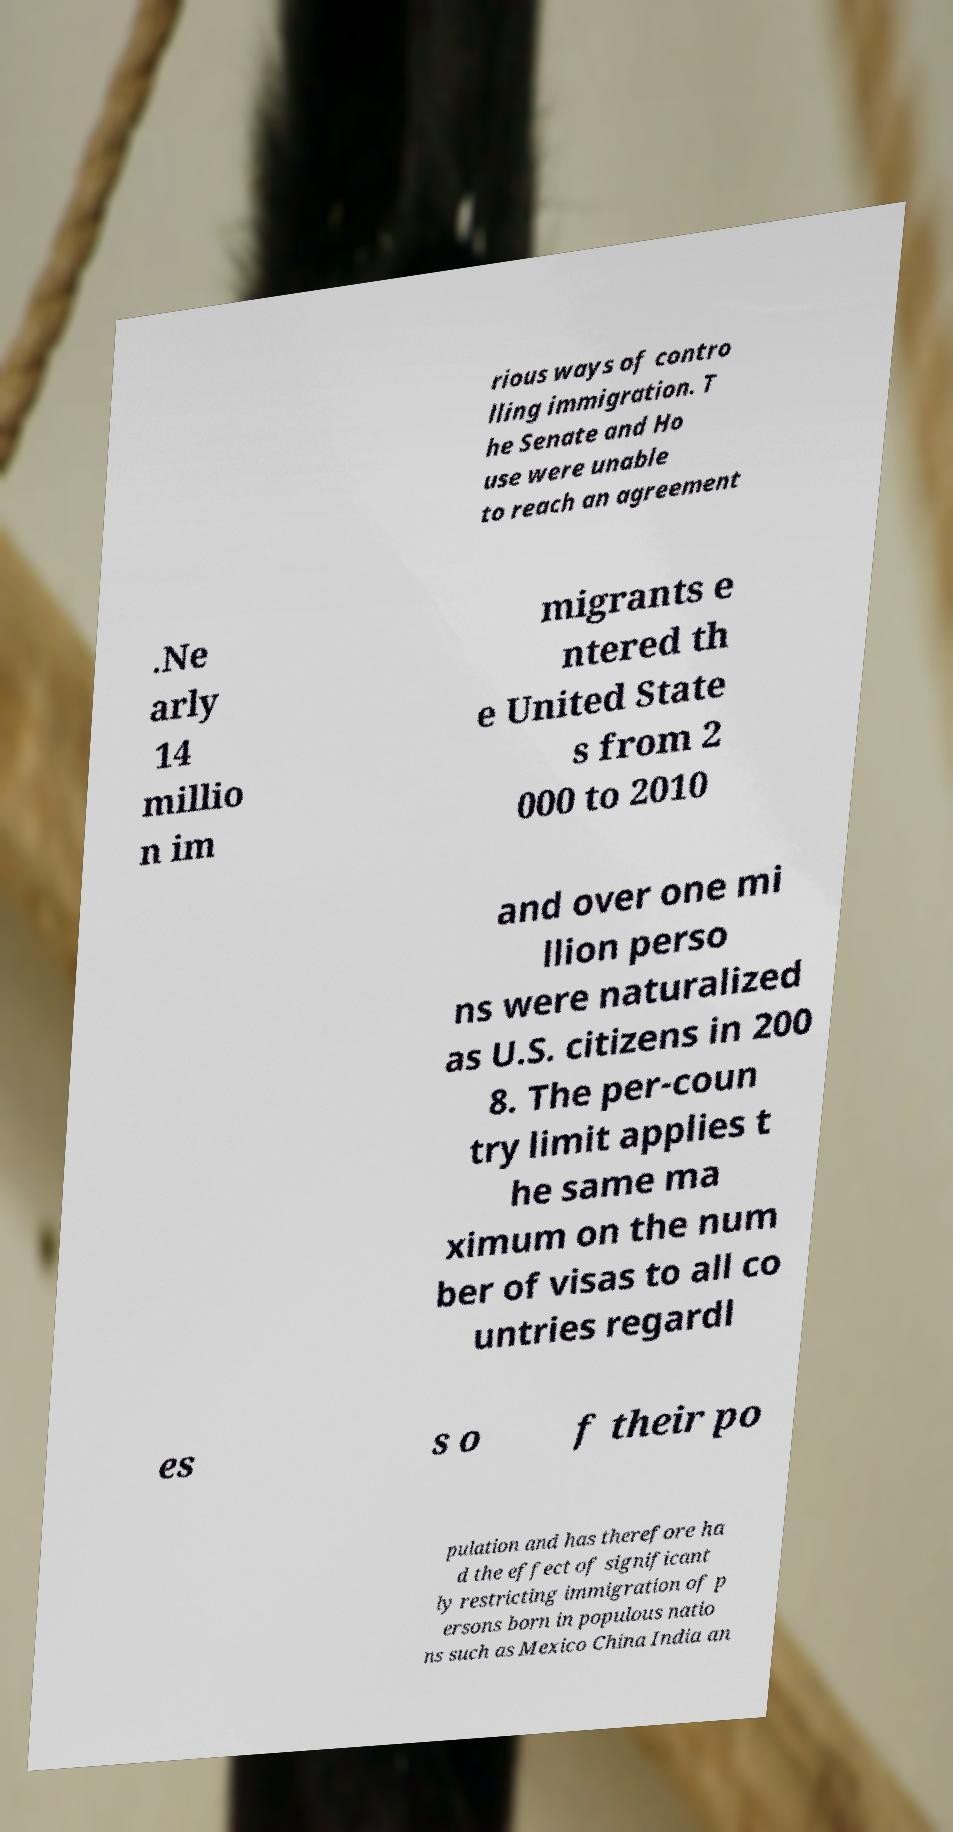There's text embedded in this image that I need extracted. Can you transcribe it verbatim? rious ways of contro lling immigration. T he Senate and Ho use were unable to reach an agreement .Ne arly 14 millio n im migrants e ntered th e United State s from 2 000 to 2010 and over one mi llion perso ns were naturalized as U.S. citizens in 200 8. The per-coun try limit applies t he same ma ximum on the num ber of visas to all co untries regardl es s o f their po pulation and has therefore ha d the effect of significant ly restricting immigration of p ersons born in populous natio ns such as Mexico China India an 